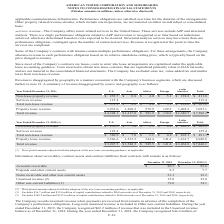According to American Tower Corporation's financial document, What does unearned revenue exclude? $56.7 million and $55.0 million of capital contributions related to DAS networks as of December 31, 2019 and 2018, respectively.. The document states: "e accounting guidance, as applicable. (2) Excludes $56.7 million and $55.0 million of capital contributions related to DAS networks as of December 31,..." Also, What does Other non-current liabilities exclude? Excludes $300.2 million and $313.6 million of capital contributions related to DAS networks as of December 31, 2019 and 2018, respectively.. The document states: "s of December 31, 2019 and 2018, respectively. (3) Excludes $300.2 million and $313.6 million of capital contributions related to DAS networks as of D..." Also, What was Prepaids and other current assets in 2019? According to the financial document, 8.3 (in millions). The relevant text states: "Prepaids and other current assets 8.3 7.7..." Also, can you calculate: What was the change in Other non-current liabilities between 2018 and 2019? Based on the calculation: 79.0-54.1, the result is 24.9 (in millions). This is based on the information: "Other non-current liabilities (3) 79.0 54.1 Other non-current liabilities (3) 79.0 54.1..." The key data points involved are: 54.1, 79.0. Also, can you calculate: What was the change in Prepaids and other current assets between 2018 and 2019? Based on the calculation: 8.3-7.7, the result is 0.6 (in millions). This is based on the information: "Prepaids and other current assets 8.3 7.7 Prepaids and other current assets 8.3 7.7..." The key data points involved are: 7.7, 8.3. Also, can you calculate: What was the percentage change in Accounts receivable between 2018 and 2019? To answer this question, I need to perform calculations using the financial data. The calculation is: ($80.5-$92.6)/$92.6, which equals -13.07 (percentage). This is based on the information: "Accounts receivable $ 80.5 $ 92.6 Accounts receivable $ 80.5 $ 92.6..." The key data points involved are: 80.5, 92.6. 